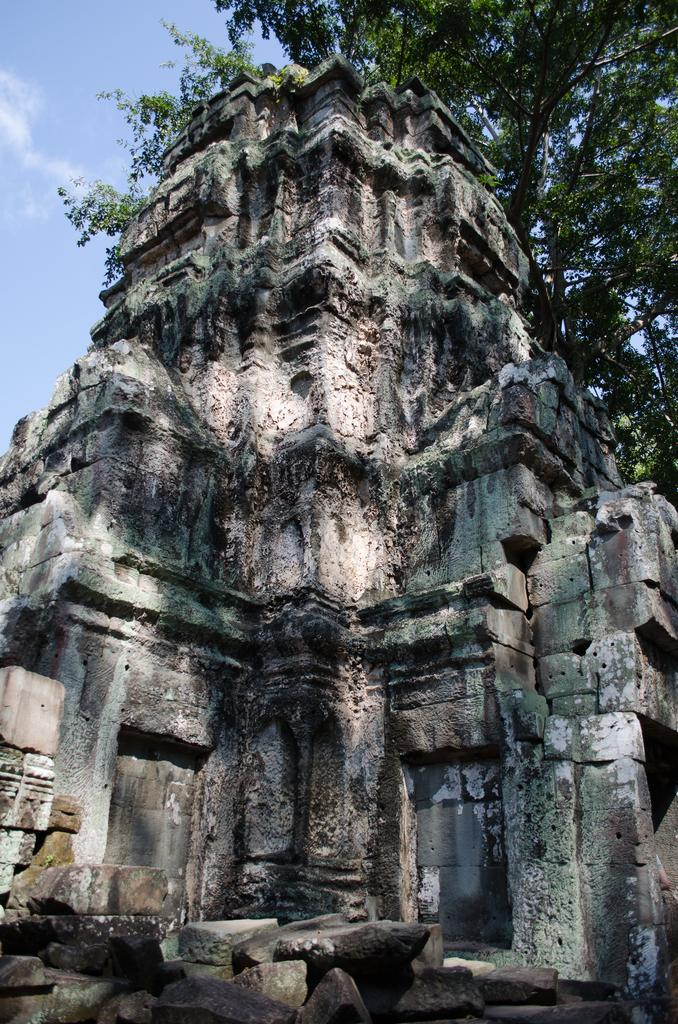What is the main structure in the center of the image? There is a temple in the center of the image. What can be seen in the background of the image? There are trees and the sky visible in the background of the image. What is the condition of the sky in the image? Clouds are present in the sky in the image. Can you suggest a garden design for the temple grounds based on the image? The image does not provide enough information to suggest a garden design for the temple grounds. 